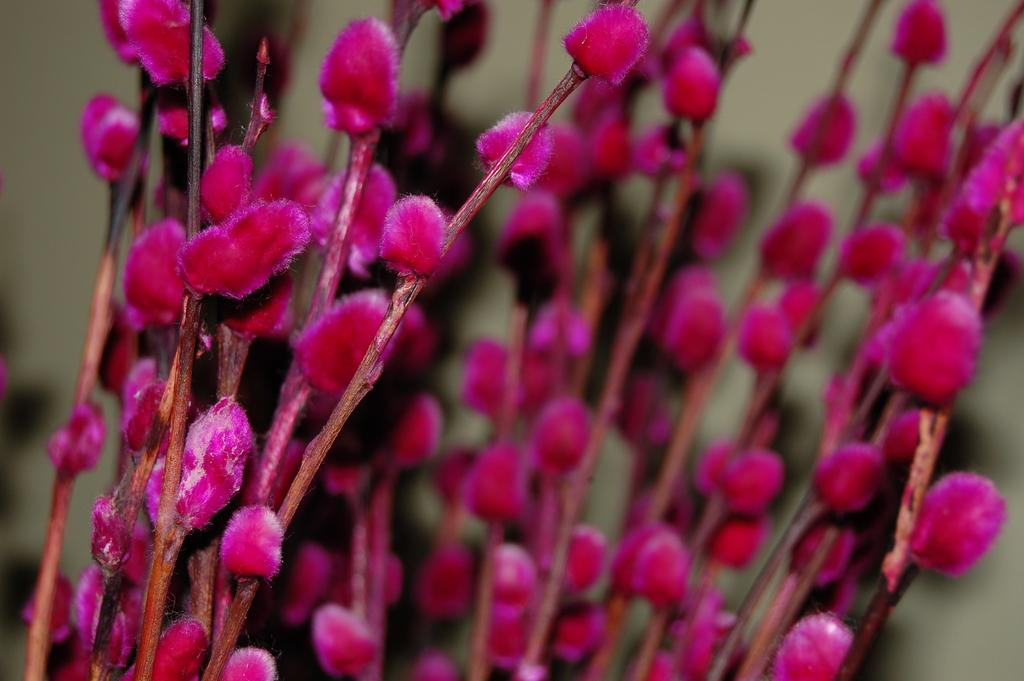What type of plants can be seen in the image? There are flowers in the image. How are the flowers arranged or positioned? The flowers are on branches. Is there a dog wearing a collar walking along the railway in the image? There is no dog, collar, or railway present in the image; it only features flowers on branches. 